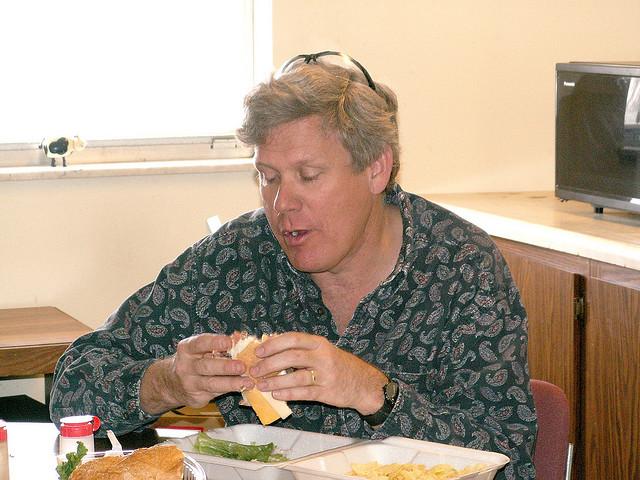Is the man married?
Quick response, please. Yes. What is the woman holding in her hands?
Short answer required. Sandwich. What is the man eating?
Write a very short answer. Sandwich. What kind of animal is on the window sill?
Write a very short answer. Cow. What room is this?
Write a very short answer. Kitchen. Does the man have a beard?
Keep it brief. No. 